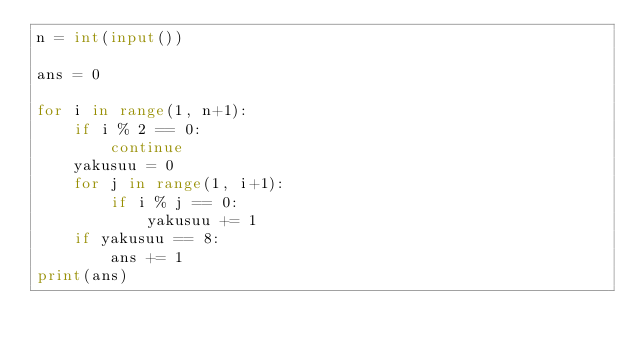Convert code to text. <code><loc_0><loc_0><loc_500><loc_500><_Python_>n = int(input())

ans = 0

for i in range(1, n+1):
    if i % 2 == 0:
        continue
    yakusuu = 0
    for j in range(1, i+1):
        if i % j == 0:
            yakusuu += 1
    if yakusuu == 8:
        ans += 1
print(ans)
</code> 